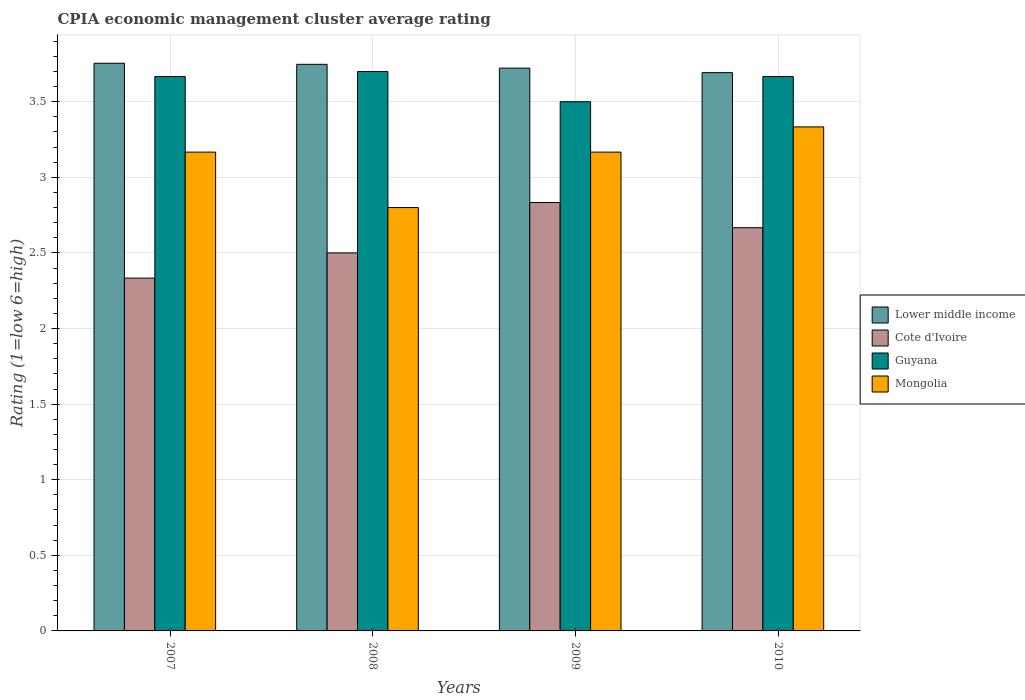Are the number of bars on each tick of the X-axis equal?
Your response must be concise. Yes. In how many cases, is the number of bars for a given year not equal to the number of legend labels?
Your response must be concise. 0. What is the CPIA rating in Lower middle income in 2008?
Provide a succinct answer. 3.75. Across all years, what is the maximum CPIA rating in Lower middle income?
Your response must be concise. 3.75. Across all years, what is the minimum CPIA rating in Lower middle income?
Your answer should be compact. 3.69. What is the total CPIA rating in Mongolia in the graph?
Provide a short and direct response. 12.47. What is the difference between the CPIA rating in Lower middle income in 2007 and that in 2009?
Provide a succinct answer. 0.03. What is the average CPIA rating in Cote d'Ivoire per year?
Give a very brief answer. 2.58. In the year 2008, what is the difference between the CPIA rating in Lower middle income and CPIA rating in Cote d'Ivoire?
Your answer should be very brief. 1.25. Is the difference between the CPIA rating in Lower middle income in 2007 and 2008 greater than the difference between the CPIA rating in Cote d'Ivoire in 2007 and 2008?
Keep it short and to the point. Yes. What is the difference between the highest and the second highest CPIA rating in Cote d'Ivoire?
Ensure brevity in your answer.  0.17. What is the difference between the highest and the lowest CPIA rating in Cote d'Ivoire?
Make the answer very short. 0.5. Is the sum of the CPIA rating in Cote d'Ivoire in 2007 and 2008 greater than the maximum CPIA rating in Mongolia across all years?
Keep it short and to the point. Yes. What does the 3rd bar from the left in 2010 represents?
Offer a terse response. Guyana. What does the 3rd bar from the right in 2007 represents?
Offer a very short reply. Cote d'Ivoire. Is it the case that in every year, the sum of the CPIA rating in Mongolia and CPIA rating in Cote d'Ivoire is greater than the CPIA rating in Guyana?
Give a very brief answer. Yes. How many bars are there?
Offer a terse response. 16. What is the difference between two consecutive major ticks on the Y-axis?
Make the answer very short. 0.5. Are the values on the major ticks of Y-axis written in scientific E-notation?
Your answer should be very brief. No. Where does the legend appear in the graph?
Provide a short and direct response. Center right. How are the legend labels stacked?
Your response must be concise. Vertical. What is the title of the graph?
Provide a short and direct response. CPIA economic management cluster average rating. What is the label or title of the X-axis?
Provide a succinct answer. Years. What is the label or title of the Y-axis?
Ensure brevity in your answer.  Rating (1=low 6=high). What is the Rating (1=low 6=high) of Lower middle income in 2007?
Offer a terse response. 3.75. What is the Rating (1=low 6=high) of Cote d'Ivoire in 2007?
Offer a terse response. 2.33. What is the Rating (1=low 6=high) of Guyana in 2007?
Provide a succinct answer. 3.67. What is the Rating (1=low 6=high) in Mongolia in 2007?
Your answer should be very brief. 3.17. What is the Rating (1=low 6=high) in Lower middle income in 2008?
Give a very brief answer. 3.75. What is the Rating (1=low 6=high) in Cote d'Ivoire in 2008?
Your response must be concise. 2.5. What is the Rating (1=low 6=high) in Guyana in 2008?
Provide a short and direct response. 3.7. What is the Rating (1=low 6=high) of Lower middle income in 2009?
Give a very brief answer. 3.72. What is the Rating (1=low 6=high) in Cote d'Ivoire in 2009?
Give a very brief answer. 2.83. What is the Rating (1=low 6=high) of Guyana in 2009?
Provide a short and direct response. 3.5. What is the Rating (1=low 6=high) of Mongolia in 2009?
Offer a terse response. 3.17. What is the Rating (1=low 6=high) of Lower middle income in 2010?
Provide a short and direct response. 3.69. What is the Rating (1=low 6=high) of Cote d'Ivoire in 2010?
Your response must be concise. 2.67. What is the Rating (1=low 6=high) of Guyana in 2010?
Make the answer very short. 3.67. What is the Rating (1=low 6=high) in Mongolia in 2010?
Give a very brief answer. 3.33. Across all years, what is the maximum Rating (1=low 6=high) of Lower middle income?
Make the answer very short. 3.75. Across all years, what is the maximum Rating (1=low 6=high) of Cote d'Ivoire?
Keep it short and to the point. 2.83. Across all years, what is the maximum Rating (1=low 6=high) of Guyana?
Provide a short and direct response. 3.7. Across all years, what is the maximum Rating (1=low 6=high) of Mongolia?
Keep it short and to the point. 3.33. Across all years, what is the minimum Rating (1=low 6=high) in Lower middle income?
Provide a short and direct response. 3.69. Across all years, what is the minimum Rating (1=low 6=high) in Cote d'Ivoire?
Keep it short and to the point. 2.33. Across all years, what is the minimum Rating (1=low 6=high) of Mongolia?
Your answer should be very brief. 2.8. What is the total Rating (1=low 6=high) in Lower middle income in the graph?
Your answer should be compact. 14.92. What is the total Rating (1=low 6=high) of Cote d'Ivoire in the graph?
Give a very brief answer. 10.33. What is the total Rating (1=low 6=high) of Guyana in the graph?
Your answer should be compact. 14.53. What is the total Rating (1=low 6=high) of Mongolia in the graph?
Your answer should be very brief. 12.47. What is the difference between the Rating (1=low 6=high) in Lower middle income in 2007 and that in 2008?
Provide a short and direct response. 0.01. What is the difference between the Rating (1=low 6=high) of Guyana in 2007 and that in 2008?
Your response must be concise. -0.03. What is the difference between the Rating (1=low 6=high) in Mongolia in 2007 and that in 2008?
Ensure brevity in your answer.  0.37. What is the difference between the Rating (1=low 6=high) in Lower middle income in 2007 and that in 2009?
Your answer should be compact. 0.03. What is the difference between the Rating (1=low 6=high) of Mongolia in 2007 and that in 2009?
Provide a succinct answer. 0. What is the difference between the Rating (1=low 6=high) in Lower middle income in 2007 and that in 2010?
Your answer should be very brief. 0.06. What is the difference between the Rating (1=low 6=high) of Cote d'Ivoire in 2007 and that in 2010?
Offer a very short reply. -0.33. What is the difference between the Rating (1=low 6=high) of Guyana in 2007 and that in 2010?
Your answer should be compact. 0. What is the difference between the Rating (1=low 6=high) in Lower middle income in 2008 and that in 2009?
Ensure brevity in your answer.  0.03. What is the difference between the Rating (1=low 6=high) in Cote d'Ivoire in 2008 and that in 2009?
Your answer should be compact. -0.33. What is the difference between the Rating (1=low 6=high) of Mongolia in 2008 and that in 2009?
Your answer should be very brief. -0.37. What is the difference between the Rating (1=low 6=high) of Lower middle income in 2008 and that in 2010?
Keep it short and to the point. 0.06. What is the difference between the Rating (1=low 6=high) of Cote d'Ivoire in 2008 and that in 2010?
Make the answer very short. -0.17. What is the difference between the Rating (1=low 6=high) of Guyana in 2008 and that in 2010?
Your response must be concise. 0.03. What is the difference between the Rating (1=low 6=high) in Mongolia in 2008 and that in 2010?
Ensure brevity in your answer.  -0.53. What is the difference between the Rating (1=low 6=high) in Lower middle income in 2009 and that in 2010?
Keep it short and to the point. 0.03. What is the difference between the Rating (1=low 6=high) of Lower middle income in 2007 and the Rating (1=low 6=high) of Cote d'Ivoire in 2008?
Make the answer very short. 1.25. What is the difference between the Rating (1=low 6=high) of Lower middle income in 2007 and the Rating (1=low 6=high) of Guyana in 2008?
Your response must be concise. 0.05. What is the difference between the Rating (1=low 6=high) of Lower middle income in 2007 and the Rating (1=low 6=high) of Mongolia in 2008?
Offer a very short reply. 0.95. What is the difference between the Rating (1=low 6=high) of Cote d'Ivoire in 2007 and the Rating (1=low 6=high) of Guyana in 2008?
Make the answer very short. -1.37. What is the difference between the Rating (1=low 6=high) of Cote d'Ivoire in 2007 and the Rating (1=low 6=high) of Mongolia in 2008?
Provide a succinct answer. -0.47. What is the difference between the Rating (1=low 6=high) in Guyana in 2007 and the Rating (1=low 6=high) in Mongolia in 2008?
Offer a very short reply. 0.87. What is the difference between the Rating (1=low 6=high) in Lower middle income in 2007 and the Rating (1=low 6=high) in Cote d'Ivoire in 2009?
Offer a very short reply. 0.92. What is the difference between the Rating (1=low 6=high) in Lower middle income in 2007 and the Rating (1=low 6=high) in Guyana in 2009?
Offer a very short reply. 0.25. What is the difference between the Rating (1=low 6=high) of Lower middle income in 2007 and the Rating (1=low 6=high) of Mongolia in 2009?
Keep it short and to the point. 0.59. What is the difference between the Rating (1=low 6=high) of Cote d'Ivoire in 2007 and the Rating (1=low 6=high) of Guyana in 2009?
Provide a short and direct response. -1.17. What is the difference between the Rating (1=low 6=high) of Cote d'Ivoire in 2007 and the Rating (1=low 6=high) of Mongolia in 2009?
Provide a succinct answer. -0.83. What is the difference between the Rating (1=low 6=high) of Lower middle income in 2007 and the Rating (1=low 6=high) of Cote d'Ivoire in 2010?
Provide a short and direct response. 1.09. What is the difference between the Rating (1=low 6=high) of Lower middle income in 2007 and the Rating (1=low 6=high) of Guyana in 2010?
Your response must be concise. 0.09. What is the difference between the Rating (1=low 6=high) of Lower middle income in 2007 and the Rating (1=low 6=high) of Mongolia in 2010?
Your response must be concise. 0.42. What is the difference between the Rating (1=low 6=high) in Cote d'Ivoire in 2007 and the Rating (1=low 6=high) in Guyana in 2010?
Provide a short and direct response. -1.33. What is the difference between the Rating (1=low 6=high) of Guyana in 2007 and the Rating (1=low 6=high) of Mongolia in 2010?
Ensure brevity in your answer.  0.33. What is the difference between the Rating (1=low 6=high) in Lower middle income in 2008 and the Rating (1=low 6=high) in Cote d'Ivoire in 2009?
Offer a very short reply. 0.91. What is the difference between the Rating (1=low 6=high) in Lower middle income in 2008 and the Rating (1=low 6=high) in Guyana in 2009?
Your response must be concise. 0.25. What is the difference between the Rating (1=low 6=high) of Lower middle income in 2008 and the Rating (1=low 6=high) of Mongolia in 2009?
Provide a succinct answer. 0.58. What is the difference between the Rating (1=low 6=high) of Cote d'Ivoire in 2008 and the Rating (1=low 6=high) of Guyana in 2009?
Your answer should be compact. -1. What is the difference between the Rating (1=low 6=high) in Guyana in 2008 and the Rating (1=low 6=high) in Mongolia in 2009?
Keep it short and to the point. 0.53. What is the difference between the Rating (1=low 6=high) of Lower middle income in 2008 and the Rating (1=low 6=high) of Cote d'Ivoire in 2010?
Give a very brief answer. 1.08. What is the difference between the Rating (1=low 6=high) of Lower middle income in 2008 and the Rating (1=low 6=high) of Guyana in 2010?
Ensure brevity in your answer.  0.08. What is the difference between the Rating (1=low 6=high) in Lower middle income in 2008 and the Rating (1=low 6=high) in Mongolia in 2010?
Ensure brevity in your answer.  0.41. What is the difference between the Rating (1=low 6=high) in Cote d'Ivoire in 2008 and the Rating (1=low 6=high) in Guyana in 2010?
Keep it short and to the point. -1.17. What is the difference between the Rating (1=low 6=high) in Cote d'Ivoire in 2008 and the Rating (1=low 6=high) in Mongolia in 2010?
Keep it short and to the point. -0.83. What is the difference between the Rating (1=low 6=high) in Guyana in 2008 and the Rating (1=low 6=high) in Mongolia in 2010?
Make the answer very short. 0.37. What is the difference between the Rating (1=low 6=high) of Lower middle income in 2009 and the Rating (1=low 6=high) of Cote d'Ivoire in 2010?
Make the answer very short. 1.06. What is the difference between the Rating (1=low 6=high) of Lower middle income in 2009 and the Rating (1=low 6=high) of Guyana in 2010?
Keep it short and to the point. 0.06. What is the difference between the Rating (1=low 6=high) of Lower middle income in 2009 and the Rating (1=low 6=high) of Mongolia in 2010?
Provide a succinct answer. 0.39. What is the difference between the Rating (1=low 6=high) of Cote d'Ivoire in 2009 and the Rating (1=low 6=high) of Mongolia in 2010?
Make the answer very short. -0.5. What is the difference between the Rating (1=low 6=high) of Guyana in 2009 and the Rating (1=low 6=high) of Mongolia in 2010?
Provide a succinct answer. 0.17. What is the average Rating (1=low 6=high) in Lower middle income per year?
Make the answer very short. 3.73. What is the average Rating (1=low 6=high) of Cote d'Ivoire per year?
Your answer should be very brief. 2.58. What is the average Rating (1=low 6=high) in Guyana per year?
Provide a short and direct response. 3.63. What is the average Rating (1=low 6=high) in Mongolia per year?
Provide a succinct answer. 3.12. In the year 2007, what is the difference between the Rating (1=low 6=high) of Lower middle income and Rating (1=low 6=high) of Cote d'Ivoire?
Offer a very short reply. 1.42. In the year 2007, what is the difference between the Rating (1=low 6=high) in Lower middle income and Rating (1=low 6=high) in Guyana?
Your answer should be compact. 0.09. In the year 2007, what is the difference between the Rating (1=low 6=high) in Lower middle income and Rating (1=low 6=high) in Mongolia?
Your answer should be very brief. 0.59. In the year 2007, what is the difference between the Rating (1=low 6=high) of Cote d'Ivoire and Rating (1=low 6=high) of Guyana?
Offer a very short reply. -1.33. In the year 2007, what is the difference between the Rating (1=low 6=high) of Guyana and Rating (1=low 6=high) of Mongolia?
Your response must be concise. 0.5. In the year 2008, what is the difference between the Rating (1=low 6=high) of Lower middle income and Rating (1=low 6=high) of Cote d'Ivoire?
Make the answer very short. 1.25. In the year 2008, what is the difference between the Rating (1=low 6=high) of Lower middle income and Rating (1=low 6=high) of Guyana?
Provide a succinct answer. 0.05. In the year 2009, what is the difference between the Rating (1=low 6=high) of Lower middle income and Rating (1=low 6=high) of Guyana?
Provide a succinct answer. 0.22. In the year 2009, what is the difference between the Rating (1=low 6=high) in Lower middle income and Rating (1=low 6=high) in Mongolia?
Offer a terse response. 0.56. In the year 2009, what is the difference between the Rating (1=low 6=high) of Guyana and Rating (1=low 6=high) of Mongolia?
Offer a terse response. 0.33. In the year 2010, what is the difference between the Rating (1=low 6=high) in Lower middle income and Rating (1=low 6=high) in Cote d'Ivoire?
Make the answer very short. 1.03. In the year 2010, what is the difference between the Rating (1=low 6=high) in Lower middle income and Rating (1=low 6=high) in Guyana?
Your response must be concise. 0.03. In the year 2010, what is the difference between the Rating (1=low 6=high) in Lower middle income and Rating (1=low 6=high) in Mongolia?
Provide a short and direct response. 0.36. In the year 2010, what is the difference between the Rating (1=low 6=high) of Cote d'Ivoire and Rating (1=low 6=high) of Mongolia?
Keep it short and to the point. -0.67. What is the ratio of the Rating (1=low 6=high) of Guyana in 2007 to that in 2008?
Make the answer very short. 0.99. What is the ratio of the Rating (1=low 6=high) of Mongolia in 2007 to that in 2008?
Give a very brief answer. 1.13. What is the ratio of the Rating (1=low 6=high) of Lower middle income in 2007 to that in 2009?
Ensure brevity in your answer.  1.01. What is the ratio of the Rating (1=low 6=high) in Cote d'Ivoire in 2007 to that in 2009?
Your response must be concise. 0.82. What is the ratio of the Rating (1=low 6=high) of Guyana in 2007 to that in 2009?
Provide a short and direct response. 1.05. What is the ratio of the Rating (1=low 6=high) of Lower middle income in 2007 to that in 2010?
Your answer should be compact. 1.02. What is the ratio of the Rating (1=low 6=high) of Cote d'Ivoire in 2007 to that in 2010?
Provide a short and direct response. 0.88. What is the ratio of the Rating (1=low 6=high) of Guyana in 2007 to that in 2010?
Give a very brief answer. 1. What is the ratio of the Rating (1=low 6=high) in Mongolia in 2007 to that in 2010?
Provide a short and direct response. 0.95. What is the ratio of the Rating (1=low 6=high) of Lower middle income in 2008 to that in 2009?
Your response must be concise. 1.01. What is the ratio of the Rating (1=low 6=high) of Cote d'Ivoire in 2008 to that in 2009?
Give a very brief answer. 0.88. What is the ratio of the Rating (1=low 6=high) of Guyana in 2008 to that in 2009?
Offer a very short reply. 1.06. What is the ratio of the Rating (1=low 6=high) of Mongolia in 2008 to that in 2009?
Provide a succinct answer. 0.88. What is the ratio of the Rating (1=low 6=high) of Lower middle income in 2008 to that in 2010?
Make the answer very short. 1.01. What is the ratio of the Rating (1=low 6=high) in Guyana in 2008 to that in 2010?
Offer a very short reply. 1.01. What is the ratio of the Rating (1=low 6=high) of Mongolia in 2008 to that in 2010?
Your answer should be very brief. 0.84. What is the ratio of the Rating (1=low 6=high) of Guyana in 2009 to that in 2010?
Offer a very short reply. 0.95. What is the difference between the highest and the second highest Rating (1=low 6=high) in Lower middle income?
Provide a short and direct response. 0.01. What is the difference between the highest and the second highest Rating (1=low 6=high) of Cote d'Ivoire?
Offer a very short reply. 0.17. What is the difference between the highest and the second highest Rating (1=low 6=high) of Mongolia?
Provide a short and direct response. 0.17. What is the difference between the highest and the lowest Rating (1=low 6=high) of Lower middle income?
Give a very brief answer. 0.06. What is the difference between the highest and the lowest Rating (1=low 6=high) of Cote d'Ivoire?
Ensure brevity in your answer.  0.5. What is the difference between the highest and the lowest Rating (1=low 6=high) in Guyana?
Give a very brief answer. 0.2. What is the difference between the highest and the lowest Rating (1=low 6=high) in Mongolia?
Make the answer very short. 0.53. 